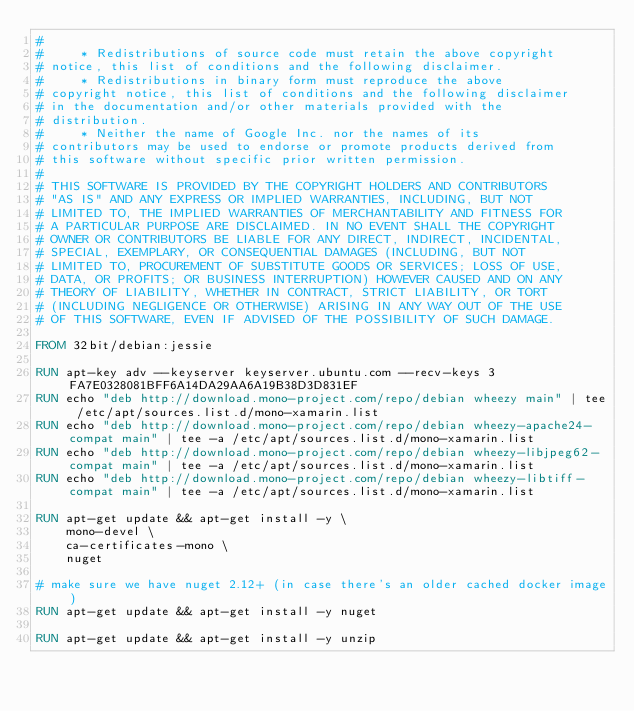Convert code to text. <code><loc_0><loc_0><loc_500><loc_500><_Dockerfile_>#
#     * Redistributions of source code must retain the above copyright
# notice, this list of conditions and the following disclaimer.
#     * Redistributions in binary form must reproduce the above
# copyright notice, this list of conditions and the following disclaimer
# in the documentation and/or other materials provided with the
# distribution.
#     * Neither the name of Google Inc. nor the names of its
# contributors may be used to endorse or promote products derived from
# this software without specific prior written permission.
#
# THIS SOFTWARE IS PROVIDED BY THE COPYRIGHT HOLDERS AND CONTRIBUTORS
# "AS IS" AND ANY EXPRESS OR IMPLIED WARRANTIES, INCLUDING, BUT NOT
# LIMITED TO, THE IMPLIED WARRANTIES OF MERCHANTABILITY AND FITNESS FOR
# A PARTICULAR PURPOSE ARE DISCLAIMED. IN NO EVENT SHALL THE COPYRIGHT
# OWNER OR CONTRIBUTORS BE LIABLE FOR ANY DIRECT, INDIRECT, INCIDENTAL,
# SPECIAL, EXEMPLARY, OR CONSEQUENTIAL DAMAGES (INCLUDING, BUT NOT
# LIMITED TO, PROCUREMENT OF SUBSTITUTE GOODS OR SERVICES; LOSS OF USE,
# DATA, OR PROFITS; OR BUSINESS INTERRUPTION) HOWEVER CAUSED AND ON ANY
# THEORY OF LIABILITY, WHETHER IN CONTRACT, STRICT LIABILITY, OR TORT
# (INCLUDING NEGLIGENCE OR OTHERWISE) ARISING IN ANY WAY OUT OF THE USE
# OF THIS SOFTWARE, EVEN IF ADVISED OF THE POSSIBILITY OF SUCH DAMAGE.

FROM 32bit/debian:jessie

RUN apt-key adv --keyserver keyserver.ubuntu.com --recv-keys 3FA7E0328081BFF6A14DA29AA6A19B38D3D831EF
RUN echo "deb http://download.mono-project.com/repo/debian wheezy main" | tee /etc/apt/sources.list.d/mono-xamarin.list
RUN echo "deb http://download.mono-project.com/repo/debian wheezy-apache24-compat main" | tee -a /etc/apt/sources.list.d/mono-xamarin.list
RUN echo "deb http://download.mono-project.com/repo/debian wheezy-libjpeg62-compat main" | tee -a /etc/apt/sources.list.d/mono-xamarin.list
RUN echo "deb http://download.mono-project.com/repo/debian wheezy-libtiff-compat main" | tee -a /etc/apt/sources.list.d/mono-xamarin.list

RUN apt-get update && apt-get install -y \
    mono-devel \
    ca-certificates-mono \
    nuget

# make sure we have nuget 2.12+ (in case there's an older cached docker image)
RUN apt-get update && apt-get install -y nuget

RUN apt-get update && apt-get install -y unzip
</code> 